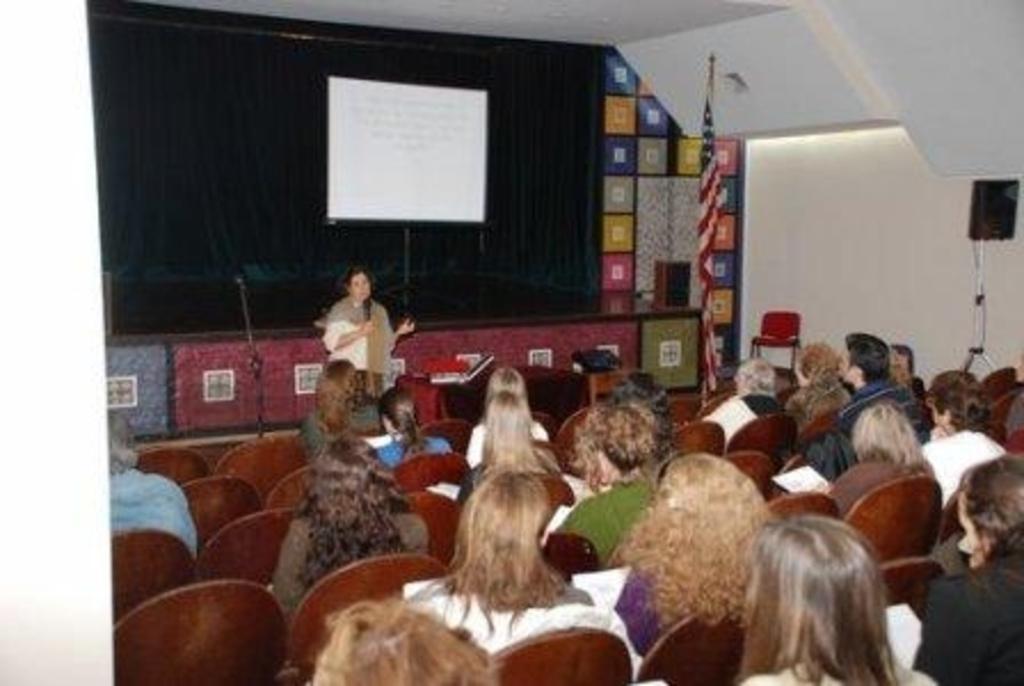Describe this image in one or two sentences. In this image there are people sitting on chairs, in front of them there is a woman standing and holding a mike in her hand, in the background there is a stage, on that stage there is a white board and a black curtain and a flag. 